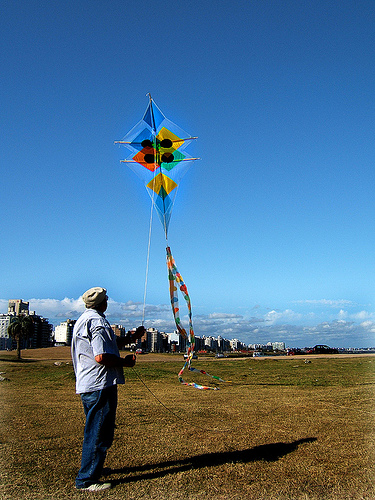How many people are pictured? 1 